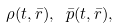<formula> <loc_0><loc_0><loc_500><loc_500>\rho ( t , \bar { r } ) , \ \bar { p } ( t , \bar { r } ) ,</formula> 